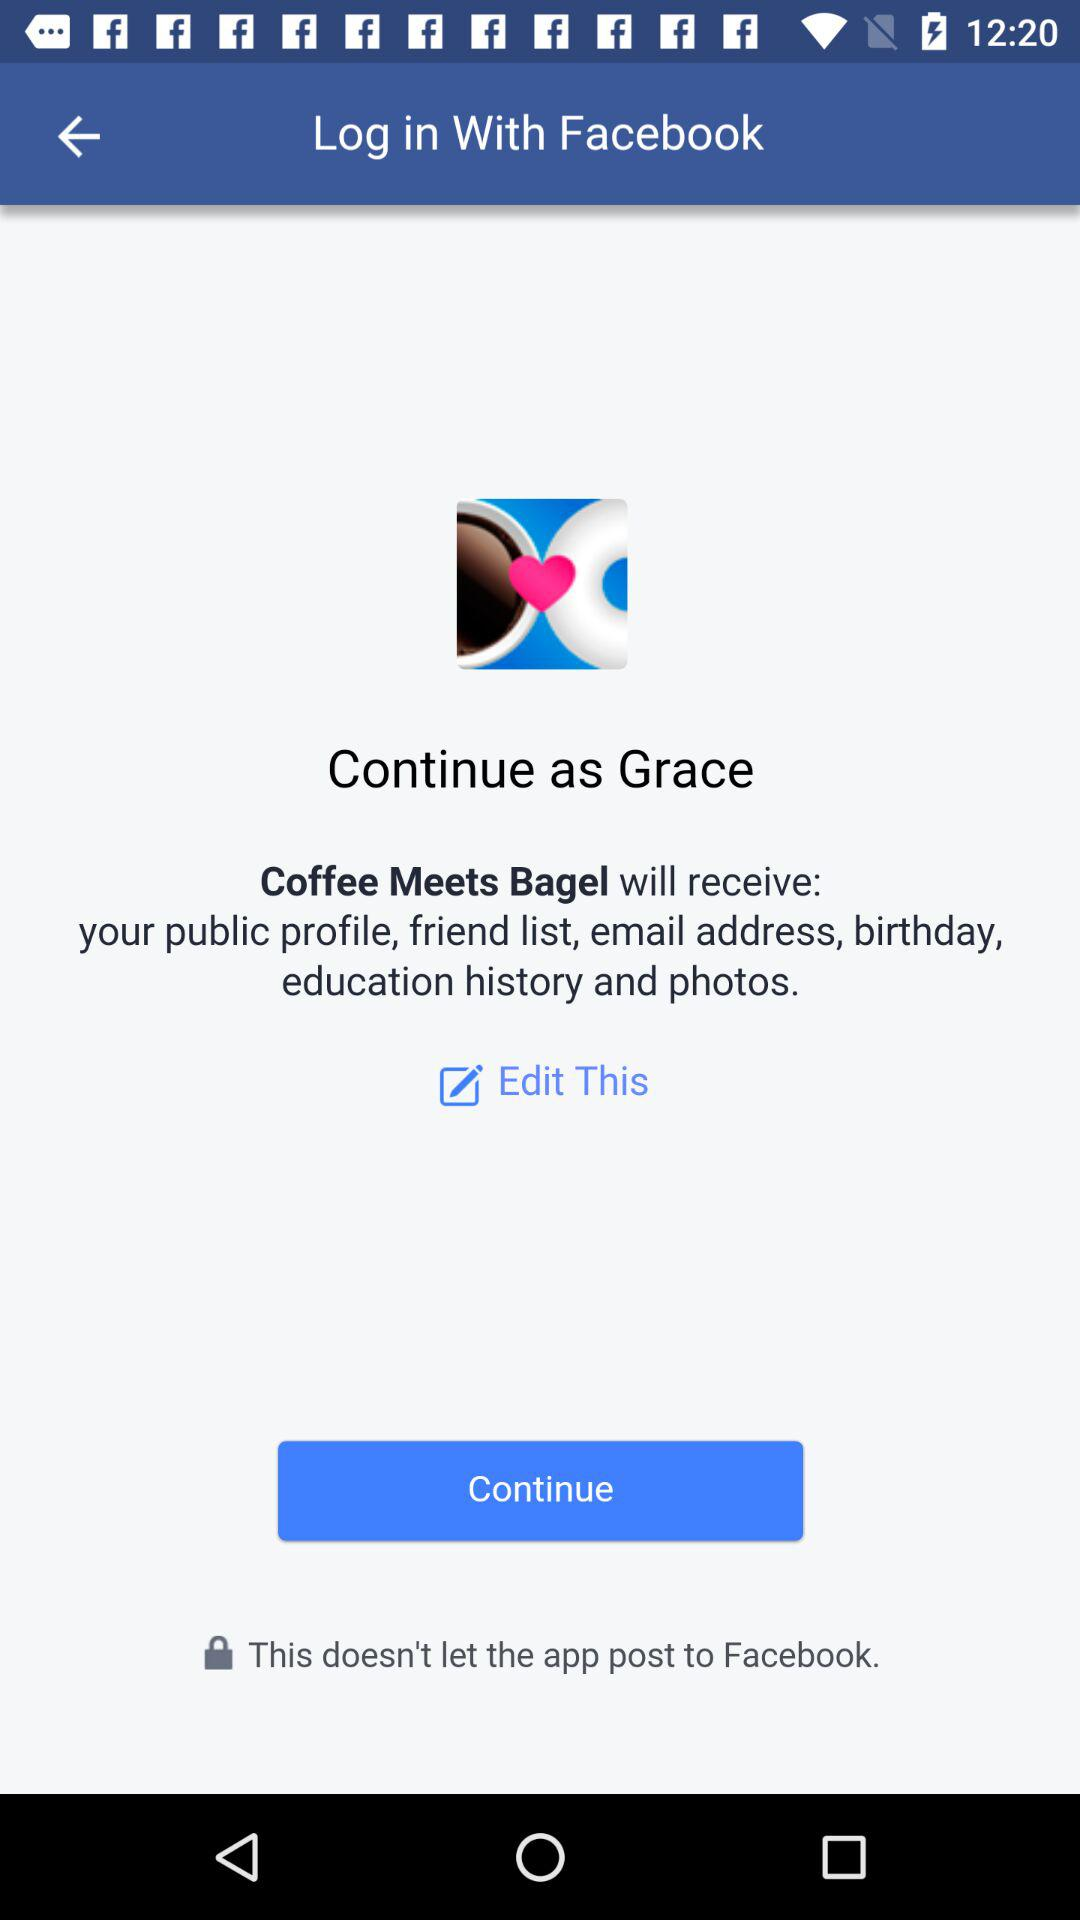What is the login name? The login name is Grace. 